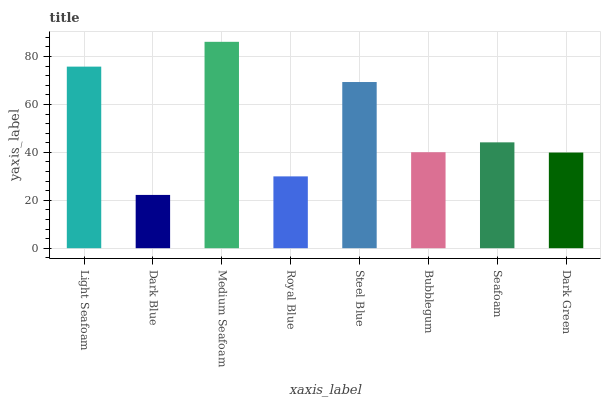Is Dark Blue the minimum?
Answer yes or no. Yes. Is Medium Seafoam the maximum?
Answer yes or no. Yes. Is Medium Seafoam the minimum?
Answer yes or no. No. Is Dark Blue the maximum?
Answer yes or no. No. Is Medium Seafoam greater than Dark Blue?
Answer yes or no. Yes. Is Dark Blue less than Medium Seafoam?
Answer yes or no. Yes. Is Dark Blue greater than Medium Seafoam?
Answer yes or no. No. Is Medium Seafoam less than Dark Blue?
Answer yes or no. No. Is Seafoam the high median?
Answer yes or no. Yes. Is Bubblegum the low median?
Answer yes or no. Yes. Is Light Seafoam the high median?
Answer yes or no. No. Is Steel Blue the low median?
Answer yes or no. No. 